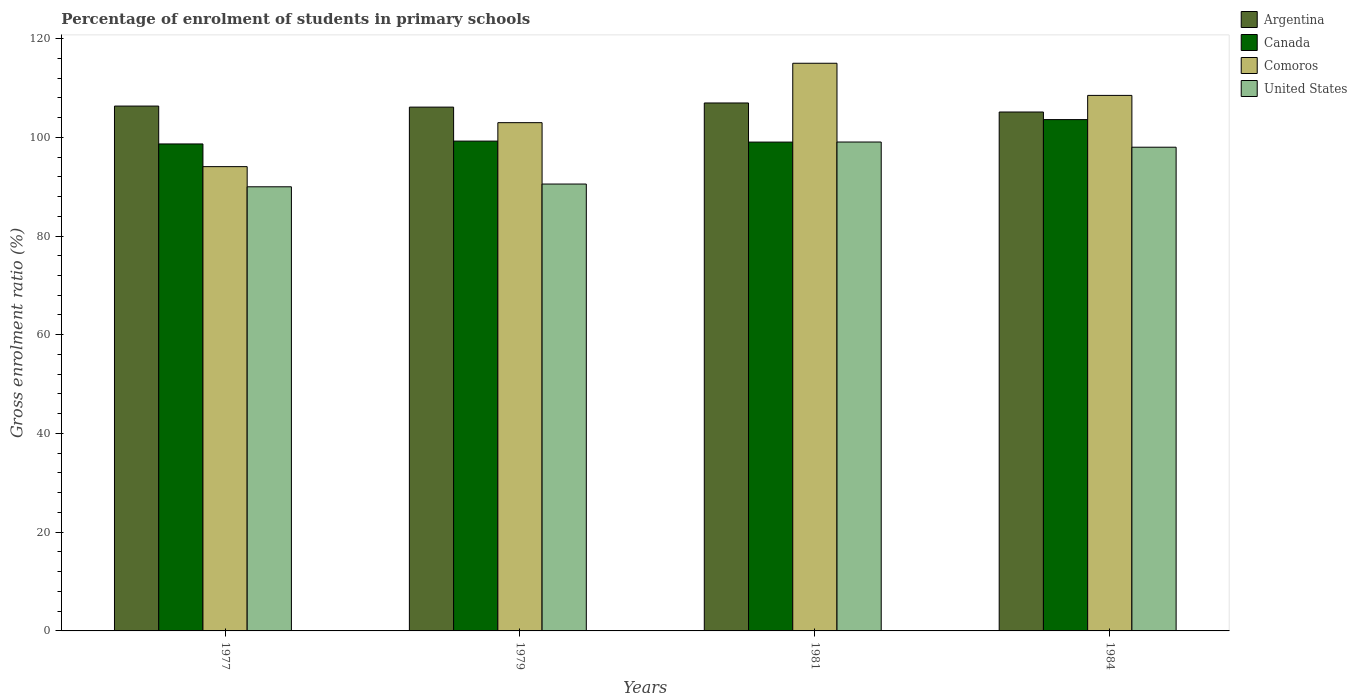How many groups of bars are there?
Your answer should be very brief. 4. How many bars are there on the 3rd tick from the left?
Provide a short and direct response. 4. How many bars are there on the 4th tick from the right?
Your answer should be very brief. 4. What is the label of the 1st group of bars from the left?
Provide a succinct answer. 1977. In how many cases, is the number of bars for a given year not equal to the number of legend labels?
Give a very brief answer. 0. What is the percentage of students enrolled in primary schools in United States in 1981?
Provide a succinct answer. 99.04. Across all years, what is the maximum percentage of students enrolled in primary schools in Comoros?
Provide a short and direct response. 115. Across all years, what is the minimum percentage of students enrolled in primary schools in Argentina?
Your answer should be very brief. 105.12. In which year was the percentage of students enrolled in primary schools in United States maximum?
Provide a short and direct response. 1981. What is the total percentage of students enrolled in primary schools in Comoros in the graph?
Keep it short and to the point. 420.49. What is the difference between the percentage of students enrolled in primary schools in Argentina in 1977 and that in 1981?
Provide a short and direct response. -0.63. What is the difference between the percentage of students enrolled in primary schools in Canada in 1984 and the percentage of students enrolled in primary schools in United States in 1979?
Your response must be concise. 13.05. What is the average percentage of students enrolled in primary schools in Comoros per year?
Ensure brevity in your answer.  105.12. In the year 1977, what is the difference between the percentage of students enrolled in primary schools in United States and percentage of students enrolled in primary schools in Comoros?
Provide a succinct answer. -4.08. What is the ratio of the percentage of students enrolled in primary schools in Argentina in 1977 to that in 1981?
Your response must be concise. 0.99. Is the percentage of students enrolled in primary schools in Canada in 1979 less than that in 1984?
Keep it short and to the point. Yes. What is the difference between the highest and the second highest percentage of students enrolled in primary schools in Comoros?
Provide a short and direct response. 6.51. What is the difference between the highest and the lowest percentage of students enrolled in primary schools in Comoros?
Provide a succinct answer. 20.94. In how many years, is the percentage of students enrolled in primary schools in Comoros greater than the average percentage of students enrolled in primary schools in Comoros taken over all years?
Give a very brief answer. 2. Is the sum of the percentage of students enrolled in primary schools in Argentina in 1977 and 1984 greater than the maximum percentage of students enrolled in primary schools in Comoros across all years?
Provide a succinct answer. Yes. Is it the case that in every year, the sum of the percentage of students enrolled in primary schools in Canada and percentage of students enrolled in primary schools in United States is greater than the sum of percentage of students enrolled in primary schools in Comoros and percentage of students enrolled in primary schools in Argentina?
Your answer should be compact. No. What does the 1st bar from the left in 1984 represents?
Your response must be concise. Argentina. What does the 4th bar from the right in 1979 represents?
Provide a short and direct response. Argentina. How many bars are there?
Your response must be concise. 16. Are all the bars in the graph horizontal?
Offer a terse response. No. Does the graph contain grids?
Offer a terse response. No. Where does the legend appear in the graph?
Offer a terse response. Top right. How are the legend labels stacked?
Ensure brevity in your answer.  Vertical. What is the title of the graph?
Keep it short and to the point. Percentage of enrolment of students in primary schools. Does "Thailand" appear as one of the legend labels in the graph?
Make the answer very short. No. What is the label or title of the X-axis?
Your answer should be compact. Years. What is the label or title of the Y-axis?
Make the answer very short. Gross enrolment ratio (%). What is the Gross enrolment ratio (%) in Argentina in 1977?
Your response must be concise. 106.32. What is the Gross enrolment ratio (%) in Canada in 1977?
Ensure brevity in your answer.  98.65. What is the Gross enrolment ratio (%) in Comoros in 1977?
Provide a succinct answer. 94.05. What is the Gross enrolment ratio (%) in United States in 1977?
Give a very brief answer. 89.97. What is the Gross enrolment ratio (%) of Argentina in 1979?
Offer a very short reply. 106.11. What is the Gross enrolment ratio (%) of Canada in 1979?
Your answer should be compact. 99.23. What is the Gross enrolment ratio (%) of Comoros in 1979?
Your answer should be very brief. 102.96. What is the Gross enrolment ratio (%) in United States in 1979?
Provide a succinct answer. 90.53. What is the Gross enrolment ratio (%) in Argentina in 1981?
Make the answer very short. 106.95. What is the Gross enrolment ratio (%) in Canada in 1981?
Provide a succinct answer. 99.03. What is the Gross enrolment ratio (%) of Comoros in 1981?
Offer a very short reply. 115. What is the Gross enrolment ratio (%) in United States in 1981?
Give a very brief answer. 99.04. What is the Gross enrolment ratio (%) in Argentina in 1984?
Offer a very short reply. 105.12. What is the Gross enrolment ratio (%) in Canada in 1984?
Offer a very short reply. 103.58. What is the Gross enrolment ratio (%) in Comoros in 1984?
Keep it short and to the point. 108.49. What is the Gross enrolment ratio (%) of United States in 1984?
Make the answer very short. 97.99. Across all years, what is the maximum Gross enrolment ratio (%) of Argentina?
Your response must be concise. 106.95. Across all years, what is the maximum Gross enrolment ratio (%) in Canada?
Give a very brief answer. 103.58. Across all years, what is the maximum Gross enrolment ratio (%) in Comoros?
Make the answer very short. 115. Across all years, what is the maximum Gross enrolment ratio (%) in United States?
Provide a succinct answer. 99.04. Across all years, what is the minimum Gross enrolment ratio (%) of Argentina?
Keep it short and to the point. 105.12. Across all years, what is the minimum Gross enrolment ratio (%) of Canada?
Your answer should be very brief. 98.65. Across all years, what is the minimum Gross enrolment ratio (%) of Comoros?
Make the answer very short. 94.05. Across all years, what is the minimum Gross enrolment ratio (%) in United States?
Your answer should be very brief. 89.97. What is the total Gross enrolment ratio (%) of Argentina in the graph?
Give a very brief answer. 424.5. What is the total Gross enrolment ratio (%) in Canada in the graph?
Your response must be concise. 400.48. What is the total Gross enrolment ratio (%) of Comoros in the graph?
Your response must be concise. 420.49. What is the total Gross enrolment ratio (%) of United States in the graph?
Keep it short and to the point. 377.52. What is the difference between the Gross enrolment ratio (%) in Argentina in 1977 and that in 1979?
Your answer should be compact. 0.21. What is the difference between the Gross enrolment ratio (%) of Canada in 1977 and that in 1979?
Make the answer very short. -0.58. What is the difference between the Gross enrolment ratio (%) in Comoros in 1977 and that in 1979?
Your answer should be very brief. -8.91. What is the difference between the Gross enrolment ratio (%) in United States in 1977 and that in 1979?
Your answer should be very brief. -0.56. What is the difference between the Gross enrolment ratio (%) in Argentina in 1977 and that in 1981?
Offer a very short reply. -0.63. What is the difference between the Gross enrolment ratio (%) of Canada in 1977 and that in 1981?
Offer a very short reply. -0.38. What is the difference between the Gross enrolment ratio (%) of Comoros in 1977 and that in 1981?
Ensure brevity in your answer.  -20.94. What is the difference between the Gross enrolment ratio (%) of United States in 1977 and that in 1981?
Offer a very short reply. -9.07. What is the difference between the Gross enrolment ratio (%) in Argentina in 1977 and that in 1984?
Your answer should be very brief. 1.2. What is the difference between the Gross enrolment ratio (%) of Canada in 1977 and that in 1984?
Offer a terse response. -4.93. What is the difference between the Gross enrolment ratio (%) of Comoros in 1977 and that in 1984?
Give a very brief answer. -14.43. What is the difference between the Gross enrolment ratio (%) of United States in 1977 and that in 1984?
Your answer should be very brief. -8.02. What is the difference between the Gross enrolment ratio (%) of Argentina in 1979 and that in 1981?
Ensure brevity in your answer.  -0.84. What is the difference between the Gross enrolment ratio (%) in Canada in 1979 and that in 1981?
Your response must be concise. 0.2. What is the difference between the Gross enrolment ratio (%) of Comoros in 1979 and that in 1981?
Provide a short and direct response. -12.03. What is the difference between the Gross enrolment ratio (%) in United States in 1979 and that in 1981?
Your answer should be very brief. -8.51. What is the difference between the Gross enrolment ratio (%) of Argentina in 1979 and that in 1984?
Give a very brief answer. 0.99. What is the difference between the Gross enrolment ratio (%) of Canada in 1979 and that in 1984?
Provide a succinct answer. -4.36. What is the difference between the Gross enrolment ratio (%) in Comoros in 1979 and that in 1984?
Your answer should be very brief. -5.52. What is the difference between the Gross enrolment ratio (%) of United States in 1979 and that in 1984?
Keep it short and to the point. -7.46. What is the difference between the Gross enrolment ratio (%) in Argentina in 1981 and that in 1984?
Your answer should be very brief. 1.83. What is the difference between the Gross enrolment ratio (%) of Canada in 1981 and that in 1984?
Offer a very short reply. -4.56. What is the difference between the Gross enrolment ratio (%) of Comoros in 1981 and that in 1984?
Keep it short and to the point. 6.51. What is the difference between the Gross enrolment ratio (%) in United States in 1981 and that in 1984?
Keep it short and to the point. 1.05. What is the difference between the Gross enrolment ratio (%) in Argentina in 1977 and the Gross enrolment ratio (%) in Canada in 1979?
Ensure brevity in your answer.  7.1. What is the difference between the Gross enrolment ratio (%) in Argentina in 1977 and the Gross enrolment ratio (%) in Comoros in 1979?
Provide a short and direct response. 3.36. What is the difference between the Gross enrolment ratio (%) of Argentina in 1977 and the Gross enrolment ratio (%) of United States in 1979?
Make the answer very short. 15.8. What is the difference between the Gross enrolment ratio (%) of Canada in 1977 and the Gross enrolment ratio (%) of Comoros in 1979?
Provide a succinct answer. -4.31. What is the difference between the Gross enrolment ratio (%) in Canada in 1977 and the Gross enrolment ratio (%) in United States in 1979?
Provide a succinct answer. 8.12. What is the difference between the Gross enrolment ratio (%) in Comoros in 1977 and the Gross enrolment ratio (%) in United States in 1979?
Your answer should be very brief. 3.53. What is the difference between the Gross enrolment ratio (%) in Argentina in 1977 and the Gross enrolment ratio (%) in Canada in 1981?
Give a very brief answer. 7.3. What is the difference between the Gross enrolment ratio (%) in Argentina in 1977 and the Gross enrolment ratio (%) in Comoros in 1981?
Make the answer very short. -8.67. What is the difference between the Gross enrolment ratio (%) in Argentina in 1977 and the Gross enrolment ratio (%) in United States in 1981?
Offer a very short reply. 7.28. What is the difference between the Gross enrolment ratio (%) of Canada in 1977 and the Gross enrolment ratio (%) of Comoros in 1981?
Provide a succinct answer. -16.35. What is the difference between the Gross enrolment ratio (%) of Canada in 1977 and the Gross enrolment ratio (%) of United States in 1981?
Provide a succinct answer. -0.39. What is the difference between the Gross enrolment ratio (%) in Comoros in 1977 and the Gross enrolment ratio (%) in United States in 1981?
Your answer should be compact. -4.99. What is the difference between the Gross enrolment ratio (%) in Argentina in 1977 and the Gross enrolment ratio (%) in Canada in 1984?
Offer a terse response. 2.74. What is the difference between the Gross enrolment ratio (%) of Argentina in 1977 and the Gross enrolment ratio (%) of Comoros in 1984?
Provide a succinct answer. -2.16. What is the difference between the Gross enrolment ratio (%) of Argentina in 1977 and the Gross enrolment ratio (%) of United States in 1984?
Your response must be concise. 8.34. What is the difference between the Gross enrolment ratio (%) in Canada in 1977 and the Gross enrolment ratio (%) in Comoros in 1984?
Make the answer very short. -9.84. What is the difference between the Gross enrolment ratio (%) of Canada in 1977 and the Gross enrolment ratio (%) of United States in 1984?
Your answer should be very brief. 0.66. What is the difference between the Gross enrolment ratio (%) in Comoros in 1977 and the Gross enrolment ratio (%) in United States in 1984?
Provide a short and direct response. -3.93. What is the difference between the Gross enrolment ratio (%) in Argentina in 1979 and the Gross enrolment ratio (%) in Canada in 1981?
Offer a very short reply. 7.09. What is the difference between the Gross enrolment ratio (%) in Argentina in 1979 and the Gross enrolment ratio (%) in Comoros in 1981?
Make the answer very short. -8.88. What is the difference between the Gross enrolment ratio (%) in Argentina in 1979 and the Gross enrolment ratio (%) in United States in 1981?
Give a very brief answer. 7.07. What is the difference between the Gross enrolment ratio (%) of Canada in 1979 and the Gross enrolment ratio (%) of Comoros in 1981?
Offer a very short reply. -15.77. What is the difference between the Gross enrolment ratio (%) of Canada in 1979 and the Gross enrolment ratio (%) of United States in 1981?
Your response must be concise. 0.19. What is the difference between the Gross enrolment ratio (%) of Comoros in 1979 and the Gross enrolment ratio (%) of United States in 1981?
Give a very brief answer. 3.92. What is the difference between the Gross enrolment ratio (%) in Argentina in 1979 and the Gross enrolment ratio (%) in Canada in 1984?
Offer a very short reply. 2.53. What is the difference between the Gross enrolment ratio (%) in Argentina in 1979 and the Gross enrolment ratio (%) in Comoros in 1984?
Your response must be concise. -2.37. What is the difference between the Gross enrolment ratio (%) of Argentina in 1979 and the Gross enrolment ratio (%) of United States in 1984?
Your answer should be compact. 8.12. What is the difference between the Gross enrolment ratio (%) of Canada in 1979 and the Gross enrolment ratio (%) of Comoros in 1984?
Make the answer very short. -9.26. What is the difference between the Gross enrolment ratio (%) of Canada in 1979 and the Gross enrolment ratio (%) of United States in 1984?
Your answer should be very brief. 1.24. What is the difference between the Gross enrolment ratio (%) of Comoros in 1979 and the Gross enrolment ratio (%) of United States in 1984?
Provide a short and direct response. 4.97. What is the difference between the Gross enrolment ratio (%) of Argentina in 1981 and the Gross enrolment ratio (%) of Canada in 1984?
Make the answer very short. 3.37. What is the difference between the Gross enrolment ratio (%) in Argentina in 1981 and the Gross enrolment ratio (%) in Comoros in 1984?
Provide a short and direct response. -1.54. What is the difference between the Gross enrolment ratio (%) in Argentina in 1981 and the Gross enrolment ratio (%) in United States in 1984?
Offer a terse response. 8.96. What is the difference between the Gross enrolment ratio (%) in Canada in 1981 and the Gross enrolment ratio (%) in Comoros in 1984?
Give a very brief answer. -9.46. What is the difference between the Gross enrolment ratio (%) of Canada in 1981 and the Gross enrolment ratio (%) of United States in 1984?
Your answer should be very brief. 1.04. What is the difference between the Gross enrolment ratio (%) in Comoros in 1981 and the Gross enrolment ratio (%) in United States in 1984?
Ensure brevity in your answer.  17.01. What is the average Gross enrolment ratio (%) in Argentina per year?
Your answer should be compact. 106.13. What is the average Gross enrolment ratio (%) of Canada per year?
Provide a short and direct response. 100.12. What is the average Gross enrolment ratio (%) of Comoros per year?
Your answer should be compact. 105.12. What is the average Gross enrolment ratio (%) in United States per year?
Keep it short and to the point. 94.38. In the year 1977, what is the difference between the Gross enrolment ratio (%) in Argentina and Gross enrolment ratio (%) in Canada?
Provide a succinct answer. 7.67. In the year 1977, what is the difference between the Gross enrolment ratio (%) of Argentina and Gross enrolment ratio (%) of Comoros?
Your answer should be compact. 12.27. In the year 1977, what is the difference between the Gross enrolment ratio (%) of Argentina and Gross enrolment ratio (%) of United States?
Provide a succinct answer. 16.35. In the year 1977, what is the difference between the Gross enrolment ratio (%) of Canada and Gross enrolment ratio (%) of Comoros?
Give a very brief answer. 4.6. In the year 1977, what is the difference between the Gross enrolment ratio (%) of Canada and Gross enrolment ratio (%) of United States?
Offer a terse response. 8.68. In the year 1977, what is the difference between the Gross enrolment ratio (%) of Comoros and Gross enrolment ratio (%) of United States?
Your answer should be very brief. 4.08. In the year 1979, what is the difference between the Gross enrolment ratio (%) in Argentina and Gross enrolment ratio (%) in Canada?
Ensure brevity in your answer.  6.89. In the year 1979, what is the difference between the Gross enrolment ratio (%) in Argentina and Gross enrolment ratio (%) in Comoros?
Your response must be concise. 3.15. In the year 1979, what is the difference between the Gross enrolment ratio (%) in Argentina and Gross enrolment ratio (%) in United States?
Provide a succinct answer. 15.58. In the year 1979, what is the difference between the Gross enrolment ratio (%) in Canada and Gross enrolment ratio (%) in Comoros?
Your response must be concise. -3.74. In the year 1979, what is the difference between the Gross enrolment ratio (%) of Canada and Gross enrolment ratio (%) of United States?
Give a very brief answer. 8.7. In the year 1979, what is the difference between the Gross enrolment ratio (%) in Comoros and Gross enrolment ratio (%) in United States?
Your response must be concise. 12.43. In the year 1981, what is the difference between the Gross enrolment ratio (%) of Argentina and Gross enrolment ratio (%) of Canada?
Give a very brief answer. 7.92. In the year 1981, what is the difference between the Gross enrolment ratio (%) in Argentina and Gross enrolment ratio (%) in Comoros?
Provide a succinct answer. -8.04. In the year 1981, what is the difference between the Gross enrolment ratio (%) of Argentina and Gross enrolment ratio (%) of United States?
Your answer should be very brief. 7.91. In the year 1981, what is the difference between the Gross enrolment ratio (%) of Canada and Gross enrolment ratio (%) of Comoros?
Provide a short and direct response. -15.97. In the year 1981, what is the difference between the Gross enrolment ratio (%) in Canada and Gross enrolment ratio (%) in United States?
Provide a succinct answer. -0.01. In the year 1981, what is the difference between the Gross enrolment ratio (%) in Comoros and Gross enrolment ratio (%) in United States?
Offer a very short reply. 15.96. In the year 1984, what is the difference between the Gross enrolment ratio (%) in Argentina and Gross enrolment ratio (%) in Canada?
Keep it short and to the point. 1.54. In the year 1984, what is the difference between the Gross enrolment ratio (%) in Argentina and Gross enrolment ratio (%) in Comoros?
Give a very brief answer. -3.37. In the year 1984, what is the difference between the Gross enrolment ratio (%) of Argentina and Gross enrolment ratio (%) of United States?
Provide a short and direct response. 7.13. In the year 1984, what is the difference between the Gross enrolment ratio (%) in Canada and Gross enrolment ratio (%) in Comoros?
Your response must be concise. -4.9. In the year 1984, what is the difference between the Gross enrolment ratio (%) of Canada and Gross enrolment ratio (%) of United States?
Offer a terse response. 5.59. In the year 1984, what is the difference between the Gross enrolment ratio (%) in Comoros and Gross enrolment ratio (%) in United States?
Ensure brevity in your answer.  10.5. What is the ratio of the Gross enrolment ratio (%) of Argentina in 1977 to that in 1979?
Make the answer very short. 1. What is the ratio of the Gross enrolment ratio (%) of Comoros in 1977 to that in 1979?
Provide a short and direct response. 0.91. What is the ratio of the Gross enrolment ratio (%) in United States in 1977 to that in 1979?
Ensure brevity in your answer.  0.99. What is the ratio of the Gross enrolment ratio (%) in Argentina in 1977 to that in 1981?
Give a very brief answer. 0.99. What is the ratio of the Gross enrolment ratio (%) in Comoros in 1977 to that in 1981?
Provide a succinct answer. 0.82. What is the ratio of the Gross enrolment ratio (%) in United States in 1977 to that in 1981?
Keep it short and to the point. 0.91. What is the ratio of the Gross enrolment ratio (%) in Argentina in 1977 to that in 1984?
Provide a short and direct response. 1.01. What is the ratio of the Gross enrolment ratio (%) in Canada in 1977 to that in 1984?
Provide a succinct answer. 0.95. What is the ratio of the Gross enrolment ratio (%) of Comoros in 1977 to that in 1984?
Make the answer very short. 0.87. What is the ratio of the Gross enrolment ratio (%) in United States in 1977 to that in 1984?
Your answer should be very brief. 0.92. What is the ratio of the Gross enrolment ratio (%) of Argentina in 1979 to that in 1981?
Ensure brevity in your answer.  0.99. What is the ratio of the Gross enrolment ratio (%) of Comoros in 1979 to that in 1981?
Offer a terse response. 0.9. What is the ratio of the Gross enrolment ratio (%) of United States in 1979 to that in 1981?
Make the answer very short. 0.91. What is the ratio of the Gross enrolment ratio (%) in Argentina in 1979 to that in 1984?
Give a very brief answer. 1.01. What is the ratio of the Gross enrolment ratio (%) of Canada in 1979 to that in 1984?
Your answer should be compact. 0.96. What is the ratio of the Gross enrolment ratio (%) of Comoros in 1979 to that in 1984?
Offer a very short reply. 0.95. What is the ratio of the Gross enrolment ratio (%) in United States in 1979 to that in 1984?
Your answer should be very brief. 0.92. What is the ratio of the Gross enrolment ratio (%) of Argentina in 1981 to that in 1984?
Your answer should be compact. 1.02. What is the ratio of the Gross enrolment ratio (%) of Canada in 1981 to that in 1984?
Offer a very short reply. 0.96. What is the ratio of the Gross enrolment ratio (%) in Comoros in 1981 to that in 1984?
Provide a short and direct response. 1.06. What is the ratio of the Gross enrolment ratio (%) of United States in 1981 to that in 1984?
Keep it short and to the point. 1.01. What is the difference between the highest and the second highest Gross enrolment ratio (%) of Argentina?
Your answer should be compact. 0.63. What is the difference between the highest and the second highest Gross enrolment ratio (%) of Canada?
Provide a succinct answer. 4.36. What is the difference between the highest and the second highest Gross enrolment ratio (%) in Comoros?
Offer a terse response. 6.51. What is the difference between the highest and the second highest Gross enrolment ratio (%) in United States?
Provide a short and direct response. 1.05. What is the difference between the highest and the lowest Gross enrolment ratio (%) in Argentina?
Offer a terse response. 1.83. What is the difference between the highest and the lowest Gross enrolment ratio (%) in Canada?
Make the answer very short. 4.93. What is the difference between the highest and the lowest Gross enrolment ratio (%) in Comoros?
Provide a short and direct response. 20.94. What is the difference between the highest and the lowest Gross enrolment ratio (%) of United States?
Ensure brevity in your answer.  9.07. 